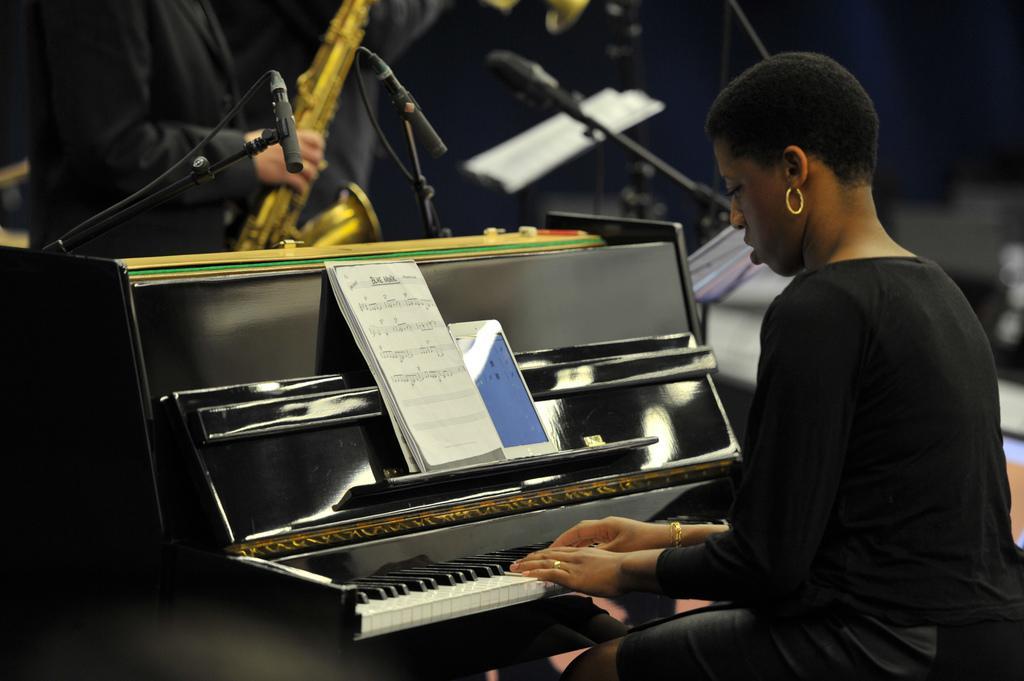Could you give a brief overview of what you see in this image? This picture shows a woman seated and playing a violin and we see a book in front of her. 